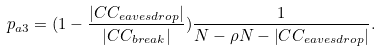Convert formula to latex. <formula><loc_0><loc_0><loc_500><loc_500>p _ { a 3 } = ( 1 - \frac { \left | C C _ { e a v e s d r o p } \right | } { \left | C C _ { b r e a k } \right | } ) \frac { 1 } { N - \rho N - \left | C C _ { e a v e s d r o p } \right | } .</formula> 